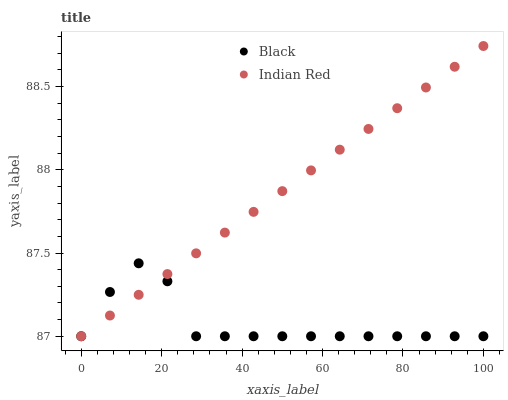Does Black have the minimum area under the curve?
Answer yes or no. Yes. Does Indian Red have the maximum area under the curve?
Answer yes or no. Yes. Does Indian Red have the minimum area under the curve?
Answer yes or no. No. Is Indian Red the smoothest?
Answer yes or no. Yes. Is Black the roughest?
Answer yes or no. Yes. Is Indian Red the roughest?
Answer yes or no. No. Does Black have the lowest value?
Answer yes or no. Yes. Does Indian Red have the highest value?
Answer yes or no. Yes. Does Indian Red intersect Black?
Answer yes or no. Yes. Is Indian Red less than Black?
Answer yes or no. No. Is Indian Red greater than Black?
Answer yes or no. No. 